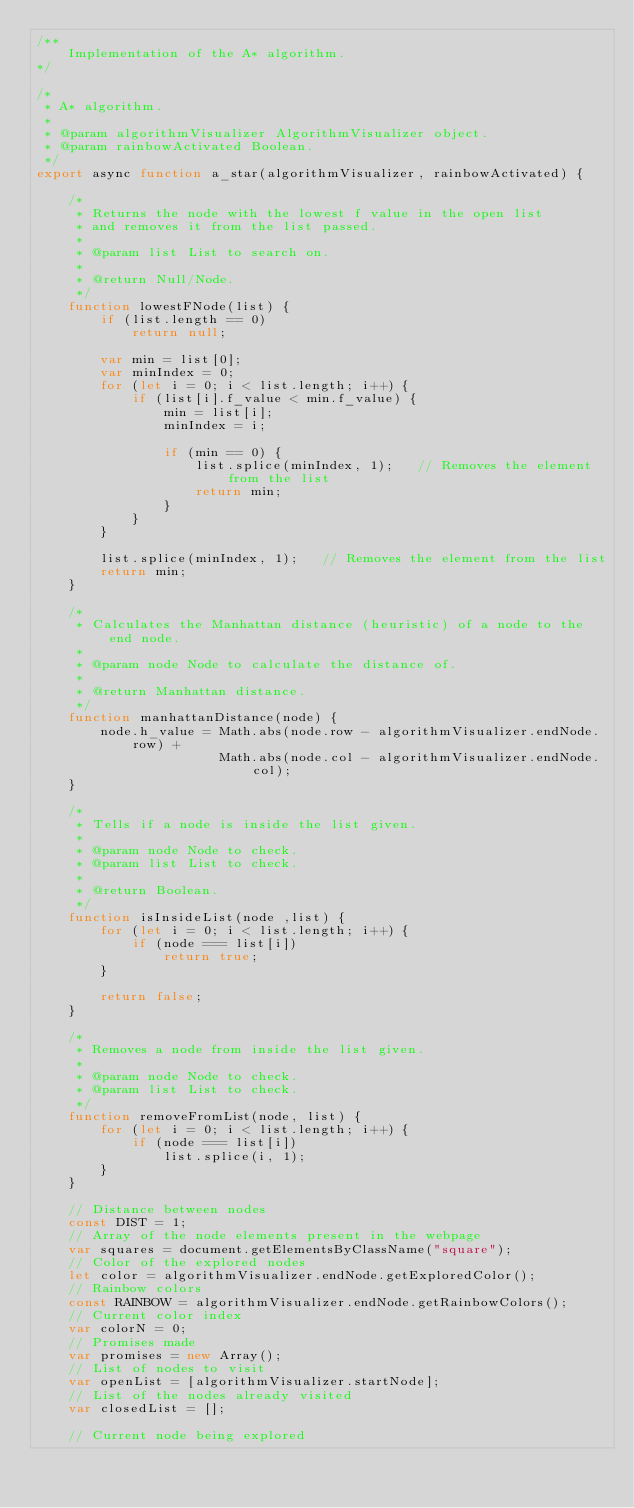Convert code to text. <code><loc_0><loc_0><loc_500><loc_500><_JavaScript_>/**
    Implementation of the A* algorithm.
*/

/*
 * A* algorithm.
 *
 * @param algorithmVisualizer AlgorithmVisualizer object.
 * @param rainbowActivated Boolean.
 */
export async function a_star(algorithmVisualizer, rainbowActivated) {

    /*
     * Returns the node with the lowest f value in the open list
     * and removes it from the list passed.
     *
     * @param list List to search on.
     * 
     * @return Null/Node.
     */
    function lowestFNode(list) {
        if (list.length == 0)
            return null;
        
        var min = list[0];
        var minIndex = 0;
        for (let i = 0; i < list.length; i++) {
            if (list[i].f_value < min.f_value) {
                min = list[i];
                minIndex = i;
                
                if (min == 0) {
                    list.splice(minIndex, 1);   // Removes the element from the list
                    return min;
                }
            }
        }

        list.splice(minIndex, 1);   // Removes the element from the list
        return min;
    }

    /*
     * Calculates the Manhattan distance (heuristic) of a node to the end node.
     *
     * @param node Node to calculate the distance of.
     * 
     * @return Manhattan distance.
     */
    function manhattanDistance(node) {
        node.h_value = Math.abs(node.row - algorithmVisualizer.endNode.row) +
                       Math.abs(node.col - algorithmVisualizer.endNode.col);
    }

    /*
     * Tells if a node is inside the list given.
     *
     * @param node Node to check.
     * @param list List to check.
     * 
     * @return Boolean.
     */
    function isInsideList(node ,list) {
        for (let i = 0; i < list.length; i++) {
            if (node === list[i])
                return true;
        }

        return false;
    }

    /*
     * Removes a node from inside the list given.
     *
     * @param node Node to check.
     * @param list List to check.
     */
    function removeFromList(node, list) {
        for (let i = 0; i < list.length; i++) {
            if (node === list[i])
                list.splice(i, 1);
        }
    }

    // Distance between nodes
    const DIST = 1;
    // Array of the node elements present in the webpage
    var squares = document.getElementsByClassName("square");
    // Color of the explored nodes
    let color = algorithmVisualizer.endNode.getExploredColor();
    // Rainbow colors
    const RAINBOW = algorithmVisualizer.endNode.getRainbowColors();
    // Current color index
    var colorN = 0;
    // Promises made
    var promises = new Array();
    // List of nodes to visit
    var openList = [algorithmVisualizer.startNode];
    // List of the nodes already visited
    var closedList = [];

    // Current node being explored</code> 